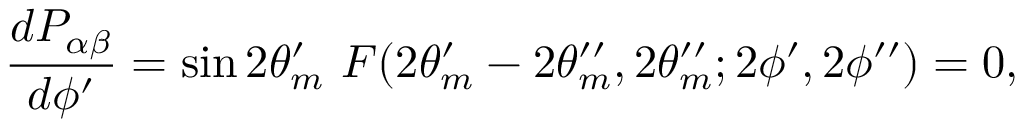Convert formula to latex. <formula><loc_0><loc_0><loc_500><loc_500>{ \frac { d P _ { \alpha \beta } } { d \phi ^ { \prime } } } = \sin 2 \theta _ { m } ^ { \prime } F ( 2 \theta _ { m } ^ { \prime } - 2 \theta _ { m } ^ { \prime \prime } , 2 \theta _ { m } ^ { \prime \prime } ; 2 \phi ^ { \prime } , 2 \phi ^ { \prime \prime } ) = 0 ,</formula> 